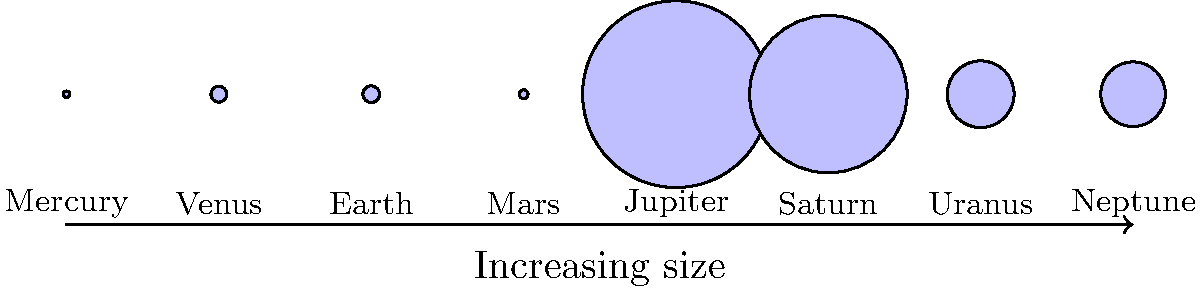As a policy-maker interested in innovative approaches, you're considering a space exploration initiative. The image shows the relative sizes of planets in our solar system. If we were to allocate resources proportionally to planet size for exploration, which two planets would require the most significant investment, and approximately how many times larger is the biggest planet compared to Earth? To answer this question, we need to analyze the relative sizes of the planets shown in the image and compare them to Earth. Let's break it down step-by-step:

1. Identify Earth: Earth is the third planet from the left.

2. Identify the largest planets: The two largest circles in the image represent Jupiter and Saturn, in that order.

3. Compare Jupiter to Earth:
   - Jupiter's diameter: 142,984 km
   - Earth's diameter: 12,756 km
   - Ratio: $\frac{142,984}{12,756} \approx 11.21$

4. Compare Saturn to Earth:
   - Saturn's diameter: 120,536 km
   - Earth's diameter: 12,756 km
   - Ratio: $\frac{120,536}{12,756} \approx 9.45$

5. Conclusion:
   - The two planets requiring the most significant investment based on size are Jupiter and Saturn.
   - Jupiter, the largest planet, is approximately 11.21 times larger than Earth in diameter.

This analysis provides a basis for proportional resource allocation in a space exploration initiative, aligning with innovative policy-making approaches that consider scientific data for decision-making.
Answer: Jupiter and Saturn; Jupiter is ~11.21 times larger than Earth. 